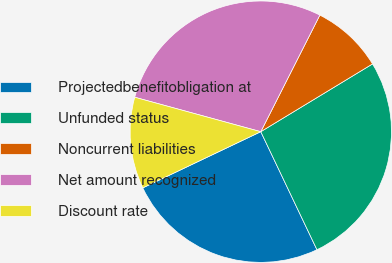Convert chart. <chart><loc_0><loc_0><loc_500><loc_500><pie_chart><fcel>Projectedbenefitobligation at<fcel>Unfunded status<fcel>Noncurrent liabilities<fcel>Net amount recognized<fcel>Discount rate<nl><fcel>25.0%<fcel>26.61%<fcel>8.86%<fcel>28.22%<fcel>11.32%<nl></chart> 